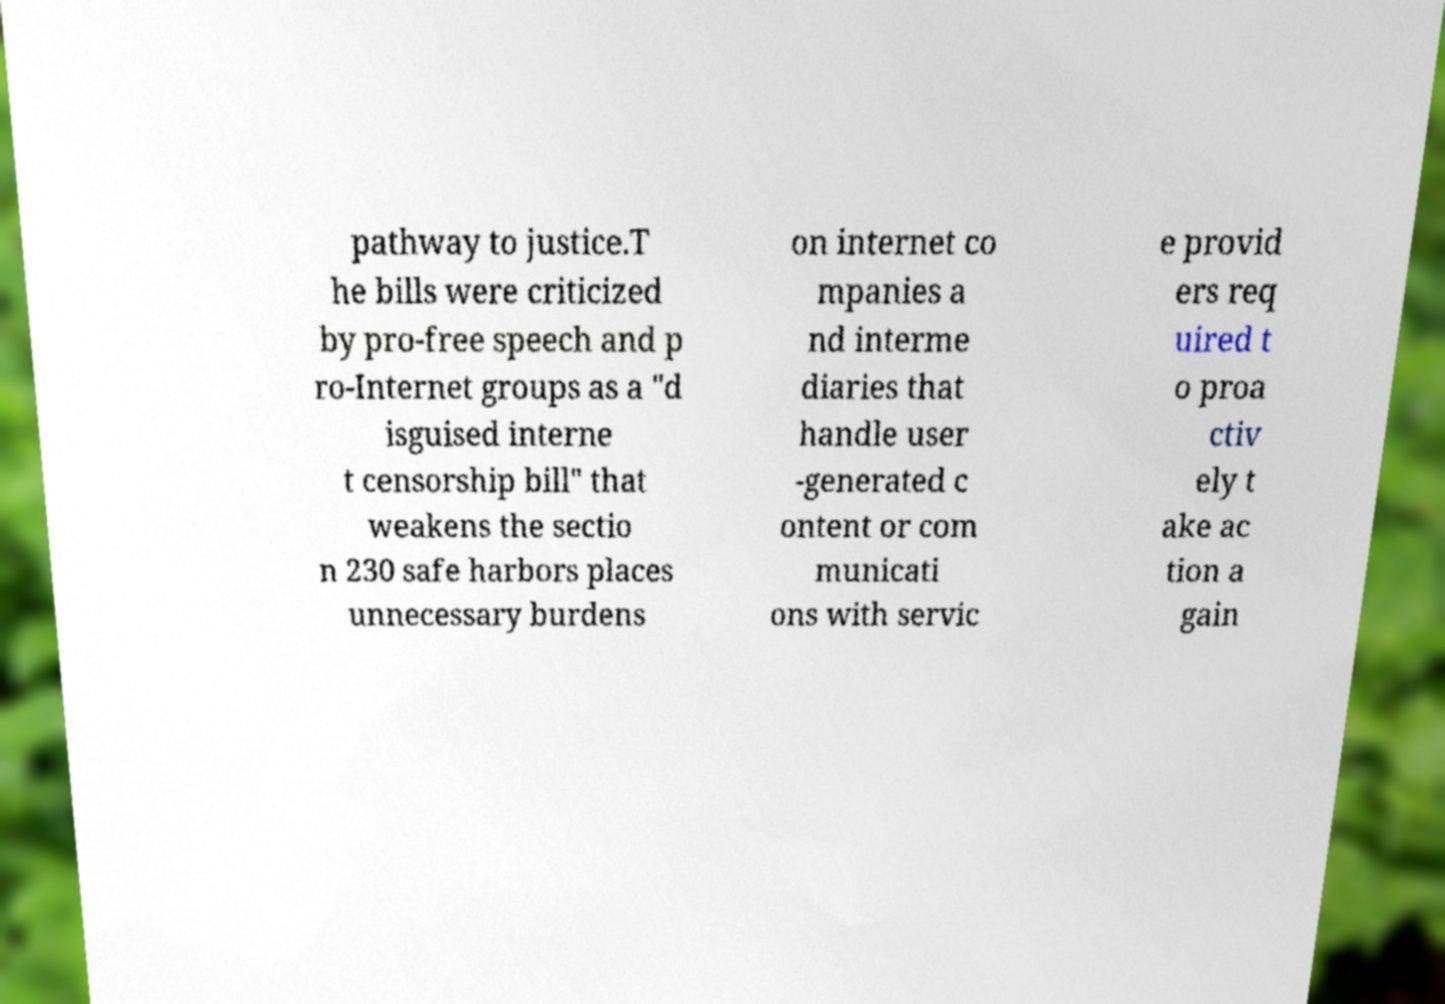Please read and relay the text visible in this image. What does it say? pathway to justice.T he bills were criticized by pro-free speech and p ro-Internet groups as a "d isguised interne t censorship bill" that weakens the sectio n 230 safe harbors places unnecessary burdens on internet co mpanies a nd interme diaries that handle user -generated c ontent or com municati ons with servic e provid ers req uired t o proa ctiv ely t ake ac tion a gain 